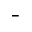Convert formula to latex. <formula><loc_0><loc_0><loc_500><loc_500>^ { - }</formula> 